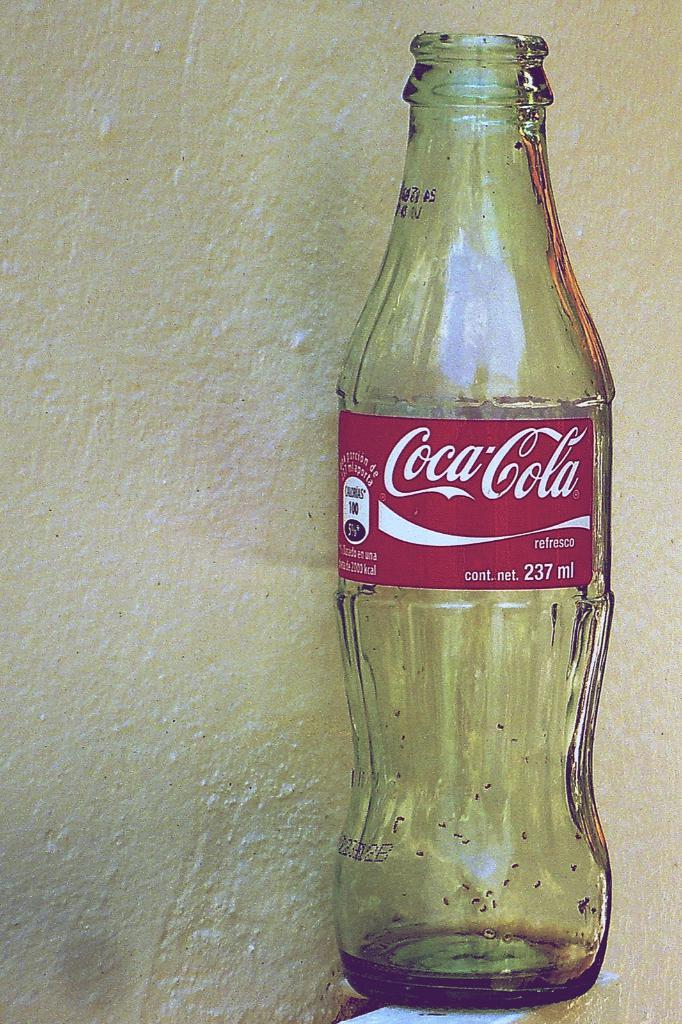What type of container is visible in the image? There is a glass bottle in the image. What is written on the glass bottle? The glass bottle has "Coca-Cola" written on it. How many apples are inside the glass bottle in the image? There are no apples present in the image; it only features a glass bottle with "Coca-Cola" written on it. 